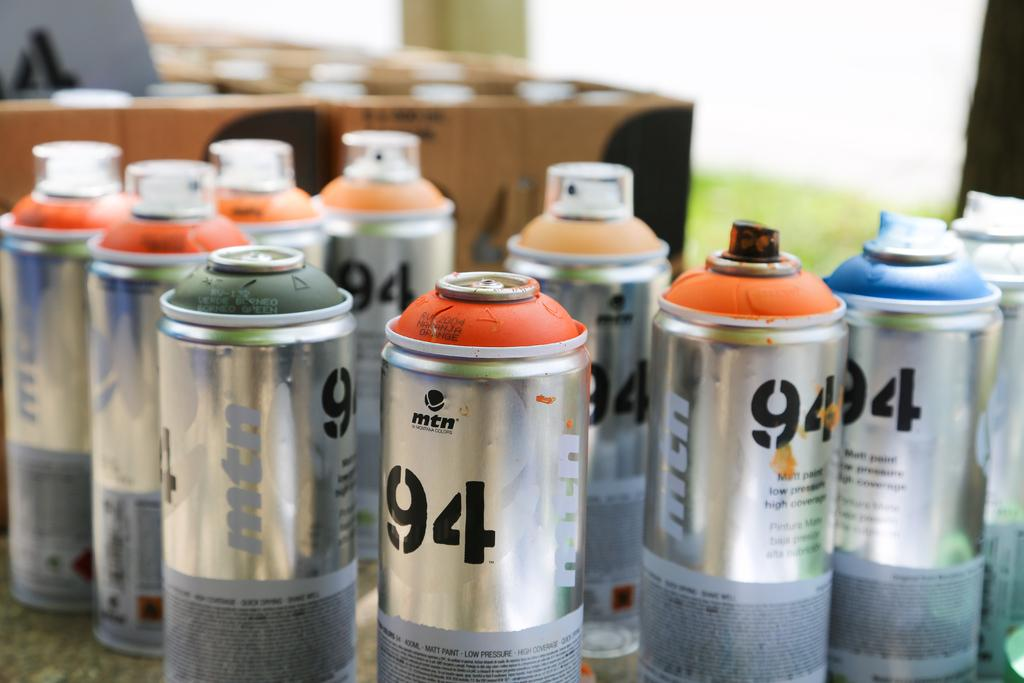<image>
Provide a brief description of the given image. Cans of paint on top of a table some of them with the cap on them and others without it they all have the number 94 on them. 